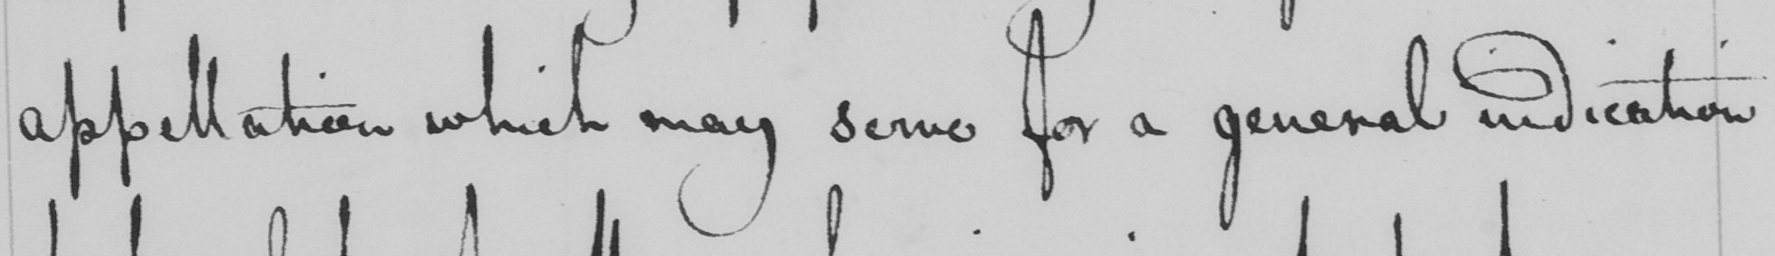What text is written in this handwritten line? appellation which may serve for a general indication 